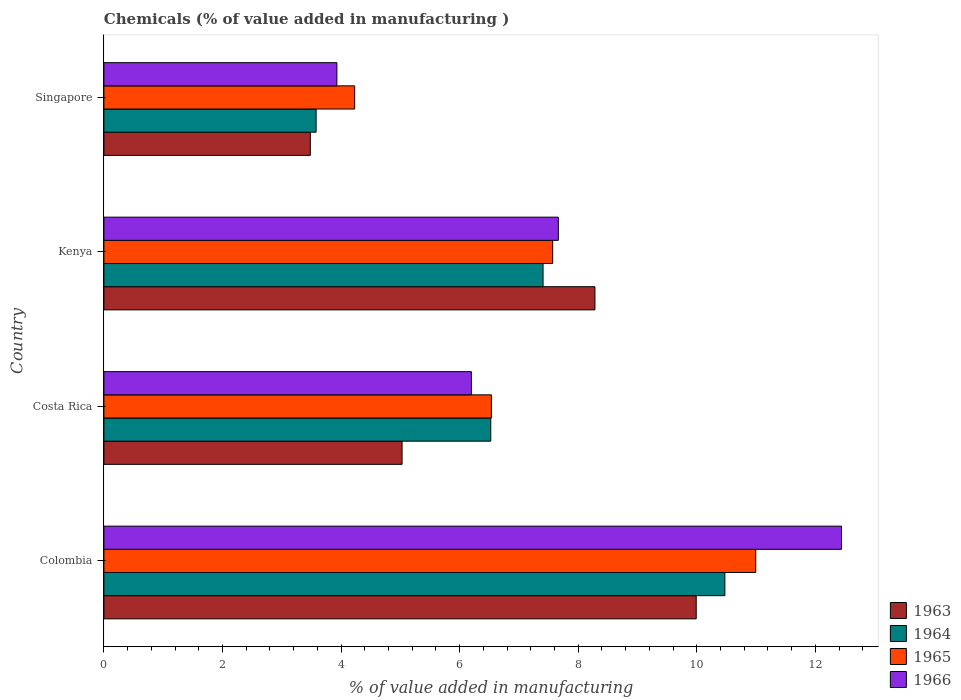How many different coloured bars are there?
Your answer should be compact. 4. What is the label of the 2nd group of bars from the top?
Your answer should be very brief. Kenya. In how many cases, is the number of bars for a given country not equal to the number of legend labels?
Offer a very short reply. 0. What is the value added in manufacturing chemicals in 1965 in Kenya?
Ensure brevity in your answer.  7.57. Across all countries, what is the maximum value added in manufacturing chemicals in 1965?
Your answer should be very brief. 10.99. Across all countries, what is the minimum value added in manufacturing chemicals in 1965?
Ensure brevity in your answer.  4.23. In which country was the value added in manufacturing chemicals in 1966 maximum?
Offer a terse response. Colombia. In which country was the value added in manufacturing chemicals in 1964 minimum?
Offer a very short reply. Singapore. What is the total value added in manufacturing chemicals in 1963 in the graph?
Offer a very short reply. 26.79. What is the difference between the value added in manufacturing chemicals in 1964 in Colombia and that in Singapore?
Keep it short and to the point. 6.89. What is the difference between the value added in manufacturing chemicals in 1963 in Colombia and the value added in manufacturing chemicals in 1964 in Kenya?
Your response must be concise. 2.58. What is the average value added in manufacturing chemicals in 1966 per country?
Provide a succinct answer. 7.56. What is the difference between the value added in manufacturing chemicals in 1965 and value added in manufacturing chemicals in 1964 in Costa Rica?
Ensure brevity in your answer.  0.01. What is the ratio of the value added in manufacturing chemicals in 1965 in Costa Rica to that in Kenya?
Make the answer very short. 0.86. What is the difference between the highest and the second highest value added in manufacturing chemicals in 1964?
Offer a very short reply. 3.07. What is the difference between the highest and the lowest value added in manufacturing chemicals in 1964?
Keep it short and to the point. 6.89. Is the sum of the value added in manufacturing chemicals in 1963 in Costa Rica and Singapore greater than the maximum value added in manufacturing chemicals in 1966 across all countries?
Offer a very short reply. No. Is it the case that in every country, the sum of the value added in manufacturing chemicals in 1963 and value added in manufacturing chemicals in 1965 is greater than the sum of value added in manufacturing chemicals in 1966 and value added in manufacturing chemicals in 1964?
Your response must be concise. No. What does the 1st bar from the top in Singapore represents?
Give a very brief answer. 1966. What does the 1st bar from the bottom in Singapore represents?
Give a very brief answer. 1963. Is it the case that in every country, the sum of the value added in manufacturing chemicals in 1965 and value added in manufacturing chemicals in 1964 is greater than the value added in manufacturing chemicals in 1963?
Give a very brief answer. Yes. How many bars are there?
Make the answer very short. 16. Are all the bars in the graph horizontal?
Ensure brevity in your answer.  Yes. What is the difference between two consecutive major ticks on the X-axis?
Your answer should be compact. 2. Does the graph contain grids?
Provide a succinct answer. No. How many legend labels are there?
Your response must be concise. 4. What is the title of the graph?
Offer a very short reply. Chemicals (% of value added in manufacturing ). What is the label or title of the X-axis?
Your answer should be very brief. % of value added in manufacturing. What is the label or title of the Y-axis?
Provide a succinct answer. Country. What is the % of value added in manufacturing in 1963 in Colombia?
Give a very brief answer. 9.99. What is the % of value added in manufacturing in 1964 in Colombia?
Offer a very short reply. 10.47. What is the % of value added in manufacturing in 1965 in Colombia?
Your answer should be compact. 10.99. What is the % of value added in manufacturing of 1966 in Colombia?
Provide a succinct answer. 12.44. What is the % of value added in manufacturing of 1963 in Costa Rica?
Ensure brevity in your answer.  5.03. What is the % of value added in manufacturing in 1964 in Costa Rica?
Your answer should be very brief. 6.53. What is the % of value added in manufacturing in 1965 in Costa Rica?
Provide a short and direct response. 6.54. What is the % of value added in manufacturing of 1966 in Costa Rica?
Offer a very short reply. 6.2. What is the % of value added in manufacturing of 1963 in Kenya?
Offer a very short reply. 8.28. What is the % of value added in manufacturing in 1964 in Kenya?
Give a very brief answer. 7.41. What is the % of value added in manufacturing of 1965 in Kenya?
Provide a short and direct response. 7.57. What is the % of value added in manufacturing in 1966 in Kenya?
Give a very brief answer. 7.67. What is the % of value added in manufacturing in 1963 in Singapore?
Your answer should be compact. 3.48. What is the % of value added in manufacturing in 1964 in Singapore?
Give a very brief answer. 3.58. What is the % of value added in manufacturing of 1965 in Singapore?
Offer a very short reply. 4.23. What is the % of value added in manufacturing of 1966 in Singapore?
Your answer should be very brief. 3.93. Across all countries, what is the maximum % of value added in manufacturing of 1963?
Offer a terse response. 9.99. Across all countries, what is the maximum % of value added in manufacturing of 1964?
Your response must be concise. 10.47. Across all countries, what is the maximum % of value added in manufacturing of 1965?
Offer a terse response. 10.99. Across all countries, what is the maximum % of value added in manufacturing of 1966?
Your response must be concise. 12.44. Across all countries, what is the minimum % of value added in manufacturing in 1963?
Give a very brief answer. 3.48. Across all countries, what is the minimum % of value added in manufacturing in 1964?
Offer a terse response. 3.58. Across all countries, what is the minimum % of value added in manufacturing of 1965?
Provide a short and direct response. 4.23. Across all countries, what is the minimum % of value added in manufacturing of 1966?
Ensure brevity in your answer.  3.93. What is the total % of value added in manufacturing of 1963 in the graph?
Ensure brevity in your answer.  26.79. What is the total % of value added in manufacturing of 1964 in the graph?
Your answer should be very brief. 27.99. What is the total % of value added in manufacturing of 1965 in the graph?
Your answer should be very brief. 29.33. What is the total % of value added in manufacturing in 1966 in the graph?
Provide a succinct answer. 30.23. What is the difference between the % of value added in manufacturing in 1963 in Colombia and that in Costa Rica?
Provide a short and direct response. 4.96. What is the difference between the % of value added in manufacturing in 1964 in Colombia and that in Costa Rica?
Ensure brevity in your answer.  3.95. What is the difference between the % of value added in manufacturing in 1965 in Colombia and that in Costa Rica?
Provide a succinct answer. 4.46. What is the difference between the % of value added in manufacturing of 1966 in Colombia and that in Costa Rica?
Make the answer very short. 6.24. What is the difference between the % of value added in manufacturing of 1963 in Colombia and that in Kenya?
Offer a very short reply. 1.71. What is the difference between the % of value added in manufacturing of 1964 in Colombia and that in Kenya?
Your answer should be very brief. 3.07. What is the difference between the % of value added in manufacturing in 1965 in Colombia and that in Kenya?
Offer a very short reply. 3.43. What is the difference between the % of value added in manufacturing in 1966 in Colombia and that in Kenya?
Keep it short and to the point. 4.78. What is the difference between the % of value added in manufacturing in 1963 in Colombia and that in Singapore?
Your answer should be very brief. 6.51. What is the difference between the % of value added in manufacturing of 1964 in Colombia and that in Singapore?
Your answer should be compact. 6.89. What is the difference between the % of value added in manufacturing of 1965 in Colombia and that in Singapore?
Keep it short and to the point. 6.76. What is the difference between the % of value added in manufacturing of 1966 in Colombia and that in Singapore?
Ensure brevity in your answer.  8.51. What is the difference between the % of value added in manufacturing in 1963 in Costa Rica and that in Kenya?
Give a very brief answer. -3.25. What is the difference between the % of value added in manufacturing of 1964 in Costa Rica and that in Kenya?
Ensure brevity in your answer.  -0.88. What is the difference between the % of value added in manufacturing in 1965 in Costa Rica and that in Kenya?
Provide a short and direct response. -1.03. What is the difference between the % of value added in manufacturing in 1966 in Costa Rica and that in Kenya?
Your answer should be compact. -1.47. What is the difference between the % of value added in manufacturing of 1963 in Costa Rica and that in Singapore?
Your response must be concise. 1.55. What is the difference between the % of value added in manufacturing of 1964 in Costa Rica and that in Singapore?
Keep it short and to the point. 2.95. What is the difference between the % of value added in manufacturing of 1965 in Costa Rica and that in Singapore?
Provide a succinct answer. 2.31. What is the difference between the % of value added in manufacturing in 1966 in Costa Rica and that in Singapore?
Make the answer very short. 2.27. What is the difference between the % of value added in manufacturing of 1963 in Kenya and that in Singapore?
Provide a succinct answer. 4.8. What is the difference between the % of value added in manufacturing of 1964 in Kenya and that in Singapore?
Your answer should be compact. 3.83. What is the difference between the % of value added in manufacturing in 1965 in Kenya and that in Singapore?
Offer a very short reply. 3.34. What is the difference between the % of value added in manufacturing in 1966 in Kenya and that in Singapore?
Your answer should be compact. 3.74. What is the difference between the % of value added in manufacturing in 1963 in Colombia and the % of value added in manufacturing in 1964 in Costa Rica?
Your answer should be compact. 3.47. What is the difference between the % of value added in manufacturing of 1963 in Colombia and the % of value added in manufacturing of 1965 in Costa Rica?
Your answer should be very brief. 3.46. What is the difference between the % of value added in manufacturing in 1963 in Colombia and the % of value added in manufacturing in 1966 in Costa Rica?
Ensure brevity in your answer.  3.79. What is the difference between the % of value added in manufacturing in 1964 in Colombia and the % of value added in manufacturing in 1965 in Costa Rica?
Give a very brief answer. 3.94. What is the difference between the % of value added in manufacturing of 1964 in Colombia and the % of value added in manufacturing of 1966 in Costa Rica?
Keep it short and to the point. 4.28. What is the difference between the % of value added in manufacturing in 1965 in Colombia and the % of value added in manufacturing in 1966 in Costa Rica?
Ensure brevity in your answer.  4.8. What is the difference between the % of value added in manufacturing of 1963 in Colombia and the % of value added in manufacturing of 1964 in Kenya?
Offer a very short reply. 2.58. What is the difference between the % of value added in manufacturing of 1963 in Colombia and the % of value added in manufacturing of 1965 in Kenya?
Offer a very short reply. 2.42. What is the difference between the % of value added in manufacturing in 1963 in Colombia and the % of value added in manufacturing in 1966 in Kenya?
Make the answer very short. 2.33. What is the difference between the % of value added in manufacturing of 1964 in Colombia and the % of value added in manufacturing of 1965 in Kenya?
Your response must be concise. 2.9. What is the difference between the % of value added in manufacturing in 1964 in Colombia and the % of value added in manufacturing in 1966 in Kenya?
Keep it short and to the point. 2.81. What is the difference between the % of value added in manufacturing of 1965 in Colombia and the % of value added in manufacturing of 1966 in Kenya?
Provide a succinct answer. 3.33. What is the difference between the % of value added in manufacturing in 1963 in Colombia and the % of value added in manufacturing in 1964 in Singapore?
Ensure brevity in your answer.  6.41. What is the difference between the % of value added in manufacturing in 1963 in Colombia and the % of value added in manufacturing in 1965 in Singapore?
Provide a succinct answer. 5.76. What is the difference between the % of value added in manufacturing in 1963 in Colombia and the % of value added in manufacturing in 1966 in Singapore?
Provide a short and direct response. 6.06. What is the difference between the % of value added in manufacturing in 1964 in Colombia and the % of value added in manufacturing in 1965 in Singapore?
Your answer should be very brief. 6.24. What is the difference between the % of value added in manufacturing in 1964 in Colombia and the % of value added in manufacturing in 1966 in Singapore?
Your answer should be compact. 6.54. What is the difference between the % of value added in manufacturing in 1965 in Colombia and the % of value added in manufacturing in 1966 in Singapore?
Offer a very short reply. 7.07. What is the difference between the % of value added in manufacturing of 1963 in Costa Rica and the % of value added in manufacturing of 1964 in Kenya?
Your answer should be compact. -2.38. What is the difference between the % of value added in manufacturing of 1963 in Costa Rica and the % of value added in manufacturing of 1965 in Kenya?
Offer a terse response. -2.54. What is the difference between the % of value added in manufacturing of 1963 in Costa Rica and the % of value added in manufacturing of 1966 in Kenya?
Offer a very short reply. -2.64. What is the difference between the % of value added in manufacturing in 1964 in Costa Rica and the % of value added in manufacturing in 1965 in Kenya?
Keep it short and to the point. -1.04. What is the difference between the % of value added in manufacturing of 1964 in Costa Rica and the % of value added in manufacturing of 1966 in Kenya?
Your response must be concise. -1.14. What is the difference between the % of value added in manufacturing in 1965 in Costa Rica and the % of value added in manufacturing in 1966 in Kenya?
Your answer should be compact. -1.13. What is the difference between the % of value added in manufacturing in 1963 in Costa Rica and the % of value added in manufacturing in 1964 in Singapore?
Ensure brevity in your answer.  1.45. What is the difference between the % of value added in manufacturing of 1963 in Costa Rica and the % of value added in manufacturing of 1965 in Singapore?
Your answer should be compact. 0.8. What is the difference between the % of value added in manufacturing in 1963 in Costa Rica and the % of value added in manufacturing in 1966 in Singapore?
Your answer should be compact. 1.1. What is the difference between the % of value added in manufacturing in 1964 in Costa Rica and the % of value added in manufacturing in 1965 in Singapore?
Keep it short and to the point. 2.3. What is the difference between the % of value added in manufacturing in 1964 in Costa Rica and the % of value added in manufacturing in 1966 in Singapore?
Offer a very short reply. 2.6. What is the difference between the % of value added in manufacturing of 1965 in Costa Rica and the % of value added in manufacturing of 1966 in Singapore?
Offer a terse response. 2.61. What is the difference between the % of value added in manufacturing in 1963 in Kenya and the % of value added in manufacturing in 1964 in Singapore?
Your answer should be very brief. 4.7. What is the difference between the % of value added in manufacturing of 1963 in Kenya and the % of value added in manufacturing of 1965 in Singapore?
Provide a succinct answer. 4.05. What is the difference between the % of value added in manufacturing of 1963 in Kenya and the % of value added in manufacturing of 1966 in Singapore?
Offer a very short reply. 4.35. What is the difference between the % of value added in manufacturing in 1964 in Kenya and the % of value added in manufacturing in 1965 in Singapore?
Provide a succinct answer. 3.18. What is the difference between the % of value added in manufacturing of 1964 in Kenya and the % of value added in manufacturing of 1966 in Singapore?
Your response must be concise. 3.48. What is the difference between the % of value added in manufacturing in 1965 in Kenya and the % of value added in manufacturing in 1966 in Singapore?
Provide a succinct answer. 3.64. What is the average % of value added in manufacturing of 1963 per country?
Your response must be concise. 6.7. What is the average % of value added in manufacturing of 1964 per country?
Keep it short and to the point. 7. What is the average % of value added in manufacturing of 1965 per country?
Offer a very short reply. 7.33. What is the average % of value added in manufacturing in 1966 per country?
Your response must be concise. 7.56. What is the difference between the % of value added in manufacturing in 1963 and % of value added in manufacturing in 1964 in Colombia?
Your answer should be very brief. -0.48. What is the difference between the % of value added in manufacturing of 1963 and % of value added in manufacturing of 1965 in Colombia?
Provide a succinct answer. -1. What is the difference between the % of value added in manufacturing of 1963 and % of value added in manufacturing of 1966 in Colombia?
Keep it short and to the point. -2.45. What is the difference between the % of value added in manufacturing in 1964 and % of value added in manufacturing in 1965 in Colombia?
Give a very brief answer. -0.52. What is the difference between the % of value added in manufacturing in 1964 and % of value added in manufacturing in 1966 in Colombia?
Offer a terse response. -1.97. What is the difference between the % of value added in manufacturing of 1965 and % of value added in manufacturing of 1966 in Colombia?
Your response must be concise. -1.45. What is the difference between the % of value added in manufacturing of 1963 and % of value added in manufacturing of 1964 in Costa Rica?
Offer a terse response. -1.5. What is the difference between the % of value added in manufacturing of 1963 and % of value added in manufacturing of 1965 in Costa Rica?
Ensure brevity in your answer.  -1.51. What is the difference between the % of value added in manufacturing in 1963 and % of value added in manufacturing in 1966 in Costa Rica?
Ensure brevity in your answer.  -1.17. What is the difference between the % of value added in manufacturing in 1964 and % of value added in manufacturing in 1965 in Costa Rica?
Give a very brief answer. -0.01. What is the difference between the % of value added in manufacturing in 1964 and % of value added in manufacturing in 1966 in Costa Rica?
Give a very brief answer. 0.33. What is the difference between the % of value added in manufacturing in 1965 and % of value added in manufacturing in 1966 in Costa Rica?
Offer a terse response. 0.34. What is the difference between the % of value added in manufacturing in 1963 and % of value added in manufacturing in 1964 in Kenya?
Ensure brevity in your answer.  0.87. What is the difference between the % of value added in manufacturing of 1963 and % of value added in manufacturing of 1965 in Kenya?
Ensure brevity in your answer.  0.71. What is the difference between the % of value added in manufacturing of 1963 and % of value added in manufacturing of 1966 in Kenya?
Ensure brevity in your answer.  0.62. What is the difference between the % of value added in manufacturing of 1964 and % of value added in manufacturing of 1965 in Kenya?
Give a very brief answer. -0.16. What is the difference between the % of value added in manufacturing in 1964 and % of value added in manufacturing in 1966 in Kenya?
Offer a terse response. -0.26. What is the difference between the % of value added in manufacturing of 1965 and % of value added in manufacturing of 1966 in Kenya?
Provide a short and direct response. -0.1. What is the difference between the % of value added in manufacturing in 1963 and % of value added in manufacturing in 1964 in Singapore?
Offer a very short reply. -0.1. What is the difference between the % of value added in manufacturing of 1963 and % of value added in manufacturing of 1965 in Singapore?
Provide a short and direct response. -0.75. What is the difference between the % of value added in manufacturing of 1963 and % of value added in manufacturing of 1966 in Singapore?
Your response must be concise. -0.45. What is the difference between the % of value added in manufacturing in 1964 and % of value added in manufacturing in 1965 in Singapore?
Make the answer very short. -0.65. What is the difference between the % of value added in manufacturing in 1964 and % of value added in manufacturing in 1966 in Singapore?
Offer a very short reply. -0.35. What is the difference between the % of value added in manufacturing of 1965 and % of value added in manufacturing of 1966 in Singapore?
Offer a very short reply. 0.3. What is the ratio of the % of value added in manufacturing in 1963 in Colombia to that in Costa Rica?
Your answer should be compact. 1.99. What is the ratio of the % of value added in manufacturing in 1964 in Colombia to that in Costa Rica?
Keep it short and to the point. 1.61. What is the ratio of the % of value added in manufacturing of 1965 in Colombia to that in Costa Rica?
Provide a succinct answer. 1.68. What is the ratio of the % of value added in manufacturing of 1966 in Colombia to that in Costa Rica?
Offer a very short reply. 2.01. What is the ratio of the % of value added in manufacturing of 1963 in Colombia to that in Kenya?
Provide a succinct answer. 1.21. What is the ratio of the % of value added in manufacturing in 1964 in Colombia to that in Kenya?
Your response must be concise. 1.41. What is the ratio of the % of value added in manufacturing in 1965 in Colombia to that in Kenya?
Ensure brevity in your answer.  1.45. What is the ratio of the % of value added in manufacturing in 1966 in Colombia to that in Kenya?
Make the answer very short. 1.62. What is the ratio of the % of value added in manufacturing in 1963 in Colombia to that in Singapore?
Offer a very short reply. 2.87. What is the ratio of the % of value added in manufacturing in 1964 in Colombia to that in Singapore?
Provide a succinct answer. 2.93. What is the ratio of the % of value added in manufacturing in 1965 in Colombia to that in Singapore?
Provide a succinct answer. 2.6. What is the ratio of the % of value added in manufacturing in 1966 in Colombia to that in Singapore?
Provide a short and direct response. 3.17. What is the ratio of the % of value added in manufacturing of 1963 in Costa Rica to that in Kenya?
Your answer should be compact. 0.61. What is the ratio of the % of value added in manufacturing of 1964 in Costa Rica to that in Kenya?
Make the answer very short. 0.88. What is the ratio of the % of value added in manufacturing of 1965 in Costa Rica to that in Kenya?
Provide a succinct answer. 0.86. What is the ratio of the % of value added in manufacturing of 1966 in Costa Rica to that in Kenya?
Give a very brief answer. 0.81. What is the ratio of the % of value added in manufacturing of 1963 in Costa Rica to that in Singapore?
Make the answer very short. 1.44. What is the ratio of the % of value added in manufacturing of 1964 in Costa Rica to that in Singapore?
Provide a succinct answer. 1.82. What is the ratio of the % of value added in manufacturing in 1965 in Costa Rica to that in Singapore?
Your answer should be very brief. 1.55. What is the ratio of the % of value added in manufacturing of 1966 in Costa Rica to that in Singapore?
Offer a very short reply. 1.58. What is the ratio of the % of value added in manufacturing of 1963 in Kenya to that in Singapore?
Ensure brevity in your answer.  2.38. What is the ratio of the % of value added in manufacturing of 1964 in Kenya to that in Singapore?
Provide a succinct answer. 2.07. What is the ratio of the % of value added in manufacturing of 1965 in Kenya to that in Singapore?
Make the answer very short. 1.79. What is the ratio of the % of value added in manufacturing of 1966 in Kenya to that in Singapore?
Provide a short and direct response. 1.95. What is the difference between the highest and the second highest % of value added in manufacturing in 1963?
Ensure brevity in your answer.  1.71. What is the difference between the highest and the second highest % of value added in manufacturing in 1964?
Your response must be concise. 3.07. What is the difference between the highest and the second highest % of value added in manufacturing of 1965?
Make the answer very short. 3.43. What is the difference between the highest and the second highest % of value added in manufacturing of 1966?
Offer a terse response. 4.78. What is the difference between the highest and the lowest % of value added in manufacturing of 1963?
Offer a terse response. 6.51. What is the difference between the highest and the lowest % of value added in manufacturing in 1964?
Provide a succinct answer. 6.89. What is the difference between the highest and the lowest % of value added in manufacturing in 1965?
Ensure brevity in your answer.  6.76. What is the difference between the highest and the lowest % of value added in manufacturing of 1966?
Your answer should be very brief. 8.51. 